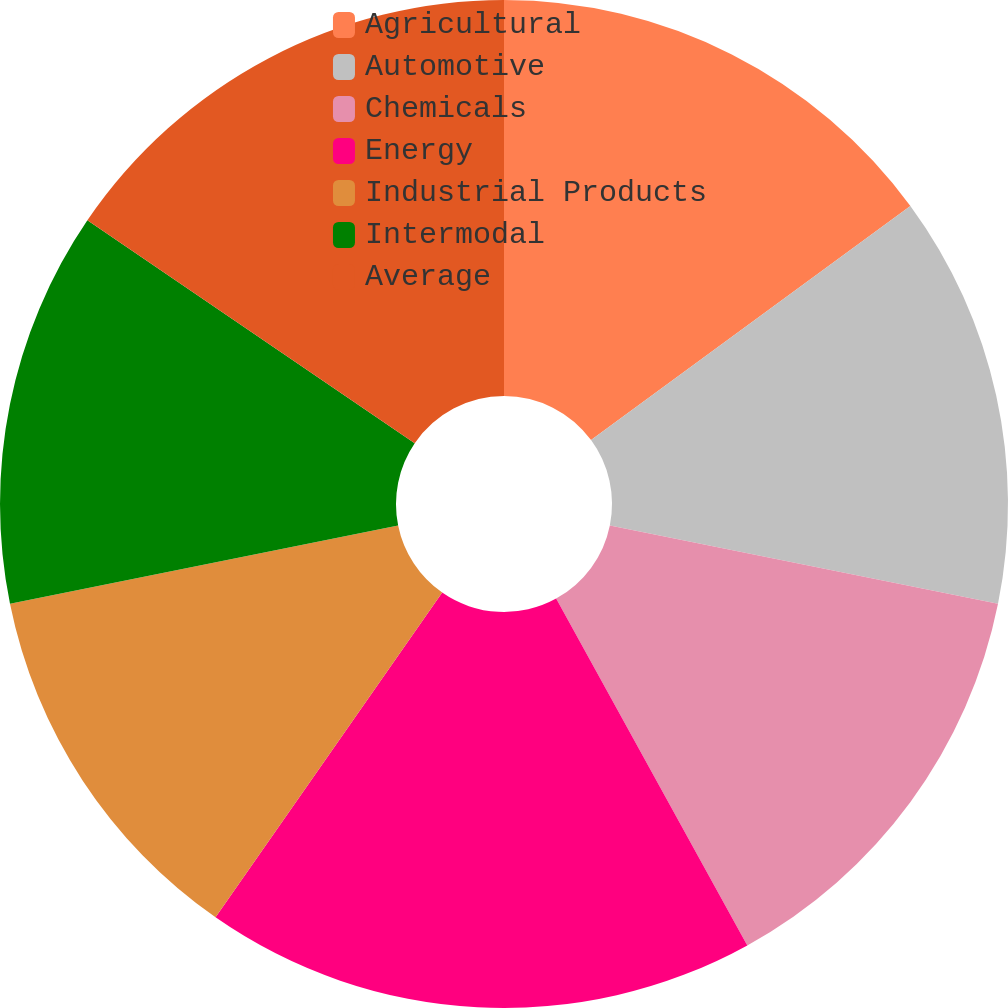<chart> <loc_0><loc_0><loc_500><loc_500><pie_chart><fcel>Agricultural<fcel>Automotive<fcel>Chemicals<fcel>Energy<fcel>Industrial Products<fcel>Intermodal<fcel>Average<nl><fcel>14.93%<fcel>13.25%<fcel>13.81%<fcel>17.72%<fcel>12.13%<fcel>12.69%<fcel>15.49%<nl></chart> 